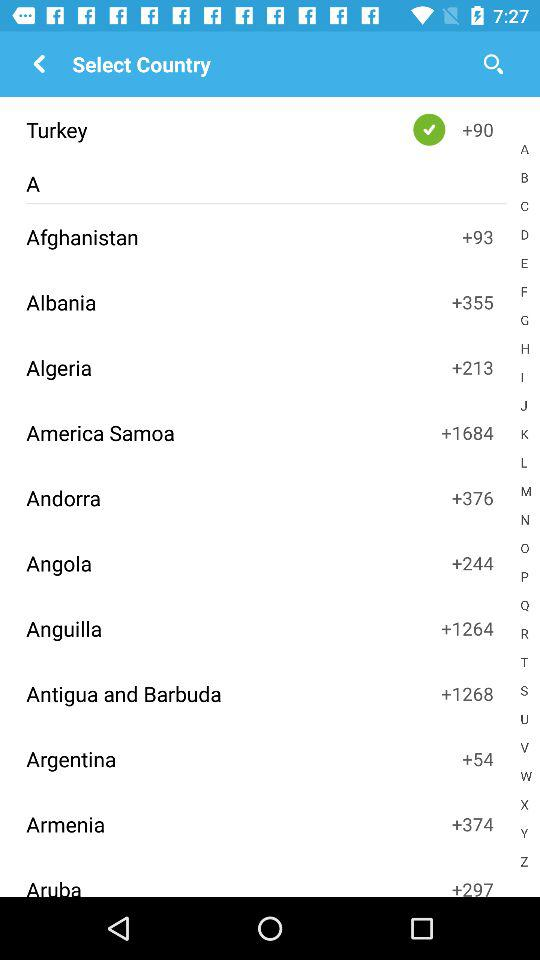What is the country code of Albania? The country code of Albania is +355. 